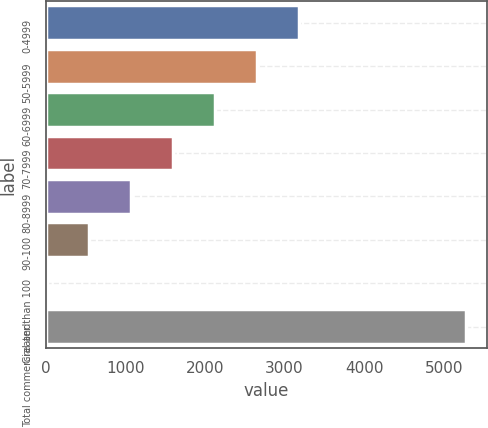Convert chart. <chart><loc_0><loc_0><loc_500><loc_500><bar_chart><fcel>0-4999<fcel>50-5999<fcel>60-6999<fcel>70-7999<fcel>80-8999<fcel>90-100<fcel>Greater than 100<fcel>Total commercial and<nl><fcel>3176.8<fcel>2650<fcel>2123.2<fcel>1596.4<fcel>1069.6<fcel>542.8<fcel>16<fcel>5284<nl></chart> 